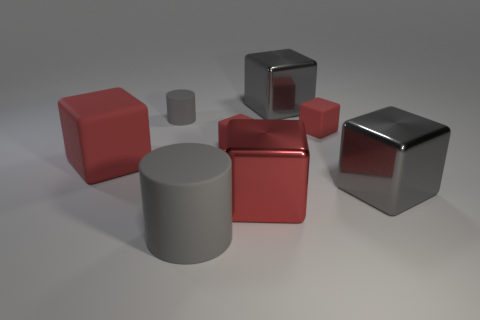Are there an equal number of matte cylinders in front of the tiny gray rubber cylinder and big red rubber objects that are on the left side of the large red rubber thing?
Your answer should be very brief. No. What size is the gray rubber cylinder that is in front of the small gray matte cylinder?
Your answer should be compact. Large. Do the big cylinder and the small rubber cylinder have the same color?
Offer a very short reply. Yes. Are there any other things that are the same shape as the big red metallic object?
Your answer should be compact. Yes. There is another cylinder that is the same color as the small cylinder; what material is it?
Provide a short and direct response. Rubber. Is the number of tiny red blocks that are on the left side of the big gray cylinder the same as the number of cubes?
Keep it short and to the point. No. Are there any red matte blocks right of the big red rubber thing?
Your answer should be very brief. Yes. Is the shape of the big red shiny thing the same as the small thing that is to the left of the big gray matte cylinder?
Offer a very short reply. No. The other cylinder that is made of the same material as the small gray cylinder is what color?
Give a very brief answer. Gray. The big cylinder has what color?
Your response must be concise. Gray. 